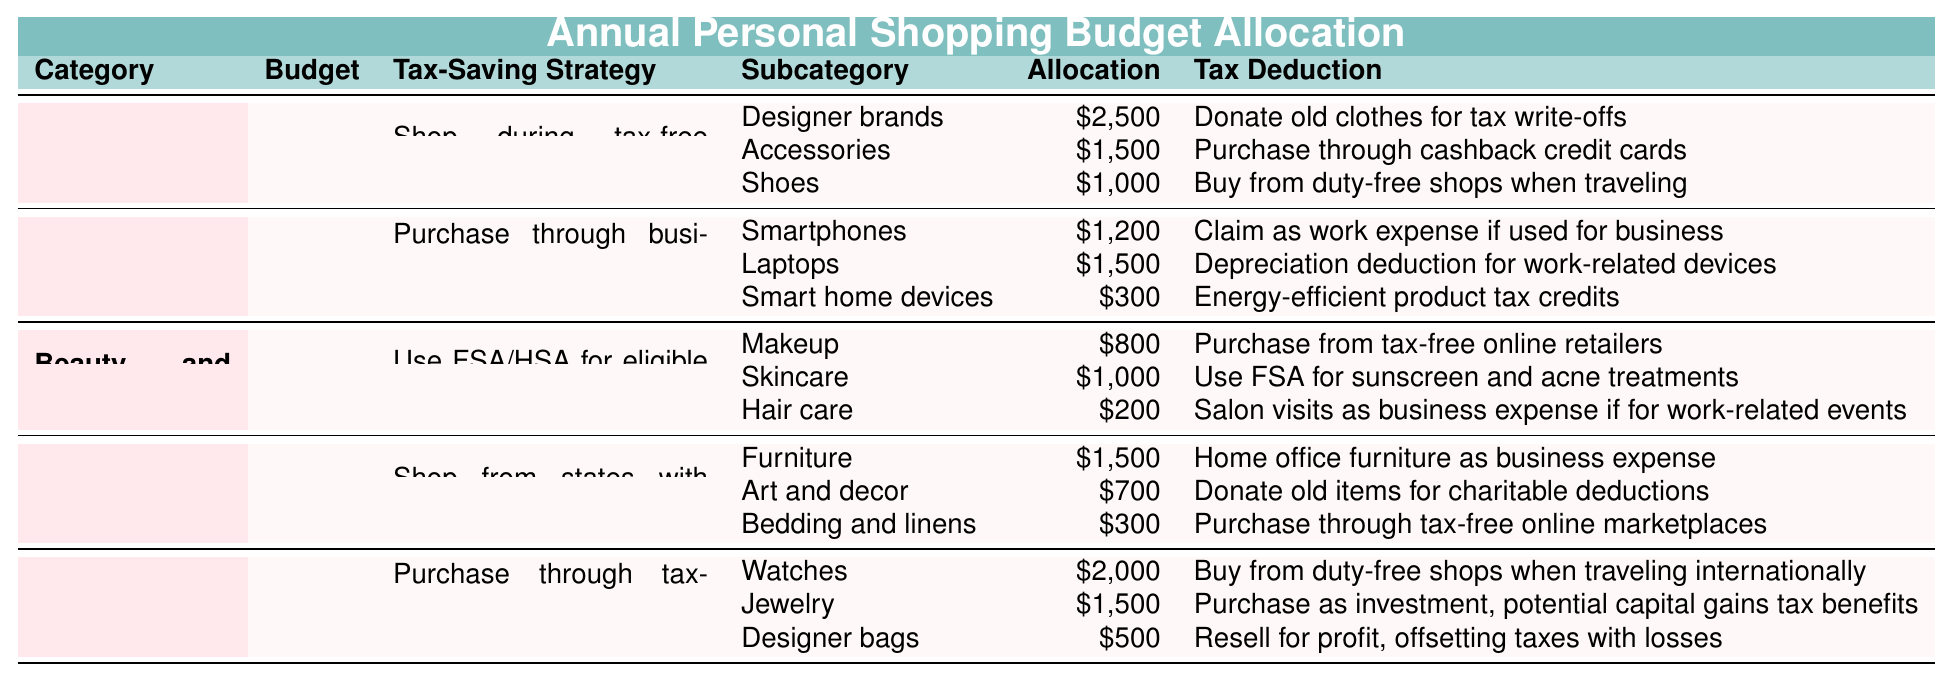What is the total budget allocated for clothing? The table specifies a budget of $5,000 for clothing listed under the "Clothing" category.
Answer: 5000 How much is allocated to accessories within the clothing budget? The subcategory "Accessories" under the clothing budget shows an allocation of $1,500.
Answer: 1500 What tax-saving strategy is recommended for beauty and cosmetics purchases? The table lists that the tax-saving strategy for beauty and cosmetics is to use FSA/HSA for eligible skincare products.
Answer: Use FSA/HSA for eligible skincare products Which category has the highest budget allocation? By comparing the budgets from all categories, "Luxury Items" with a budget of $4,000 is the highest.
Answer: Luxury Items What is the total allocation for electronics? The total allocation for electronics can be calculated by summing the amounts: $1,200 (Smartphones) + $1,500 (Laptops) + $300 (Smart home devices) = $3,000.
Answer: 3000 Is there a tax deduction related to donating old clothes within the clothing category? Yes, the table indicates that donating old clothes can be used for tax write-offs.
Answer: Yes How much of the budget for home decor is allocated to furniture? The "Furniture" subcategory under home decor has an allocation of $1,500.
Answer: 1500 If you tally the budgets of all categories, what is the grand total budget? The grand total budget is calculated by adding the budgets: $5,000 (Clothing) + $3,000 (Electronics) + $2,000 (Beauty and Cosmetics) + $2,500 (Home Decor) + $4,000 (Luxury Items) = $16,500.
Answer: 16500 Which subcategory of luxury items has the smallest budget allocation? Among the luxury items, the "Designer bags" subcategory has the smallest allocation of $500.
Answer: Designer bags If a shopper buys a $1,200 smartphone through their business, can they claim a tax deduction? Yes, the table states that a smartphone can be claimed as a work expense if used for business.
Answer: Yes What percentage of the clothing budget is allocated to designer brands? To find the percentage: (Allocation for Designer brands / Total Clothing Budget) * 100 = ($2,500 / $5,000) * 100 = 50%.
Answer: 50% Combine the allocations for both clothing and beauty subcategories, what is the total? The total allocation for clothing ($5,000) plus beauty and cosmetics ($2,000), gives a combined total of $7,000.
Answer: 7000 What total amount is allocated for makeup and skincare in the beauty category? For makeup, $800 is allocated, and for skincare, $1,000 is allocated. Thus, the total is $800 + $1,000 = $1,800.
Answer: 1800 Is it true that art and decor under the home decor category has an allocation of more than $600? No, the allocation for art and decor is $700, which is more than $600.
Answer: Yes What is the average budget allocated per category? The total budget of $16,500 divided by the 5 categories (Clothing, Electronics, Beauty and Cosmetics, Home Decor, Luxury Items) means an average of $3,300 per category.
Answer: 3300 